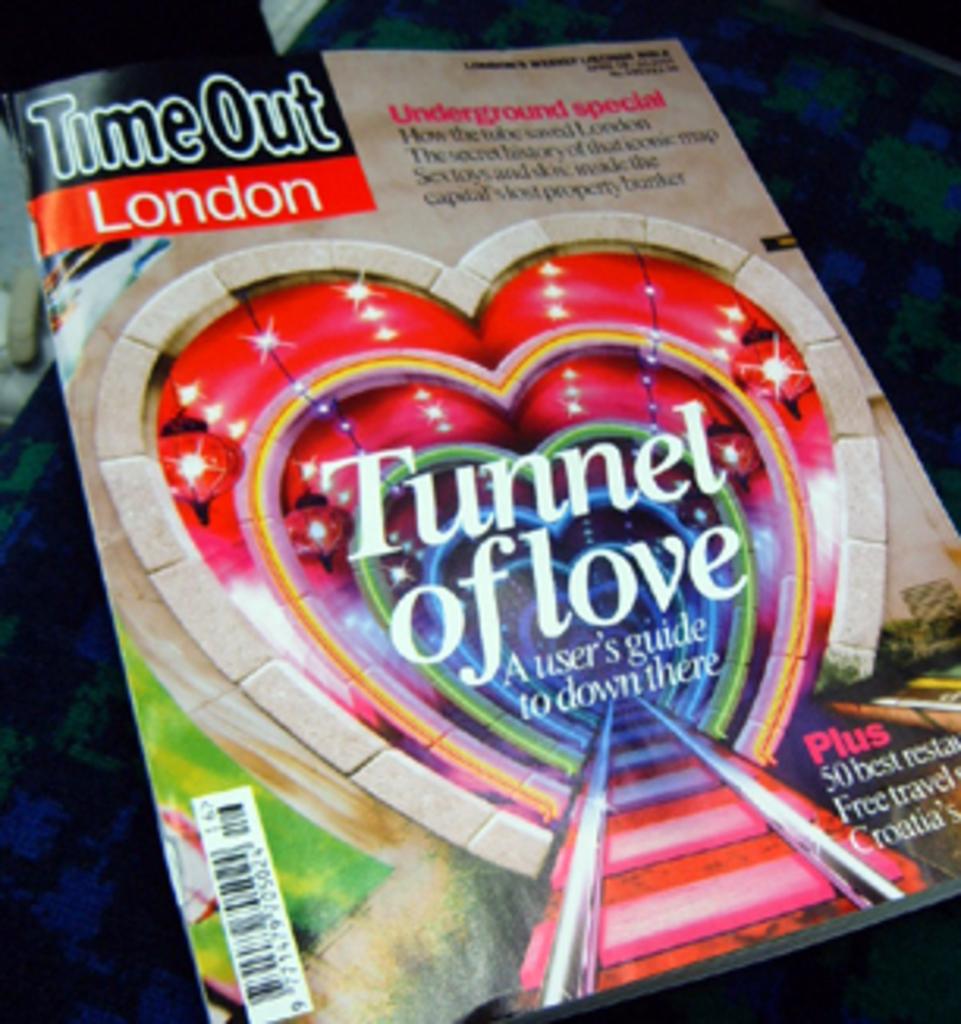Where is this magazine published?
Provide a short and direct response. London. What is the name of the magazine?
Your answer should be very brief. Timeout. 